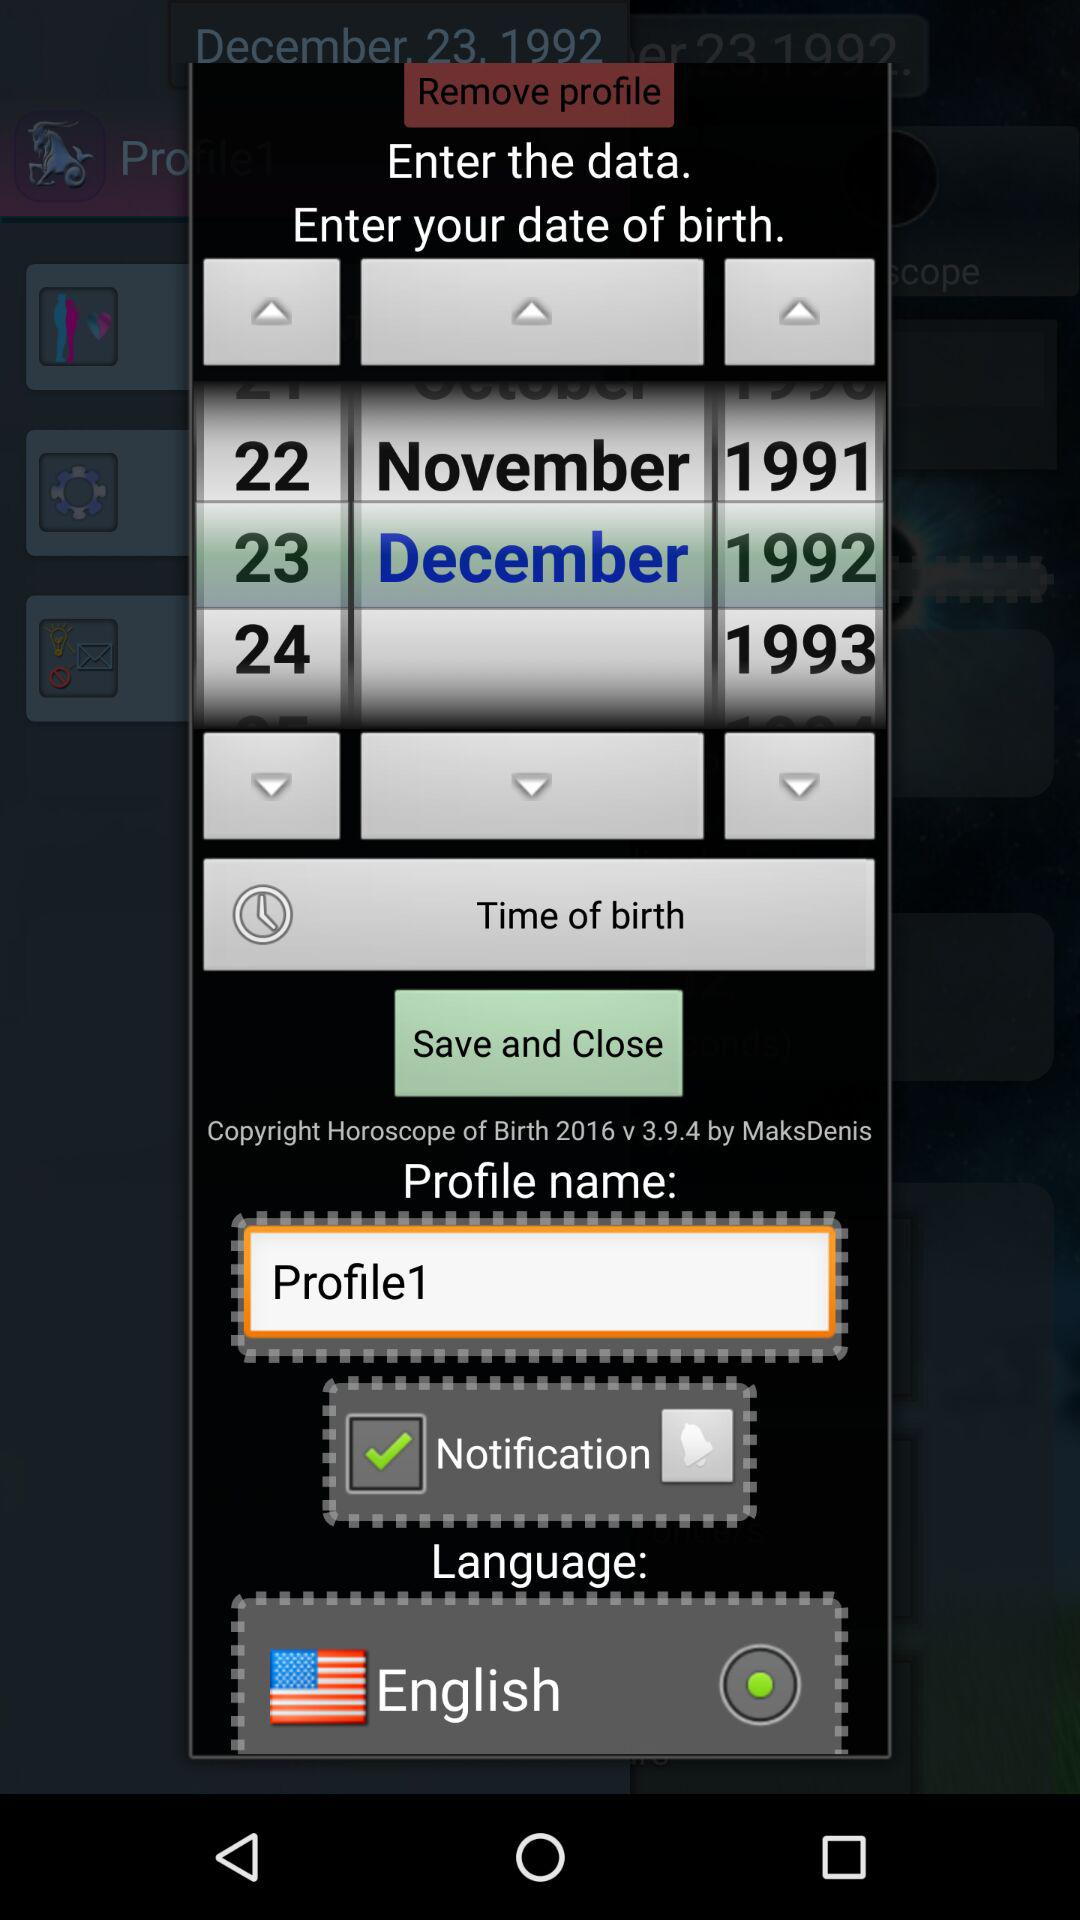What is the date of birth? The date of birth is December 23, 1992. 